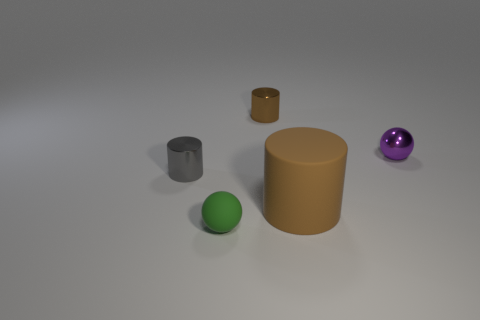Is there anything else that is the same shape as the purple metal thing?
Your answer should be very brief. Yes. Are there the same number of small objects that are on the right side of the big brown rubber object and gray metallic objects?
Keep it short and to the point. Yes. Are there any large cylinders in front of the small purple thing?
Provide a short and direct response. Yes. How big is the metal cylinder to the right of the tiny metallic cylinder in front of the ball on the right side of the big brown thing?
Your answer should be very brief. Small. Do the shiny object to the left of the small green matte thing and the brown object left of the big brown matte cylinder have the same shape?
Your answer should be compact. Yes. There is another brown object that is the same shape as the tiny brown thing; what size is it?
Provide a short and direct response. Large. How many purple balls have the same material as the big thing?
Make the answer very short. 0. What is the material of the green thing?
Give a very brief answer. Rubber. What is the shape of the brown object behind the matte cylinder that is to the right of the green matte object?
Ensure brevity in your answer.  Cylinder. What shape is the rubber object left of the tiny brown metallic cylinder?
Offer a terse response. Sphere. 